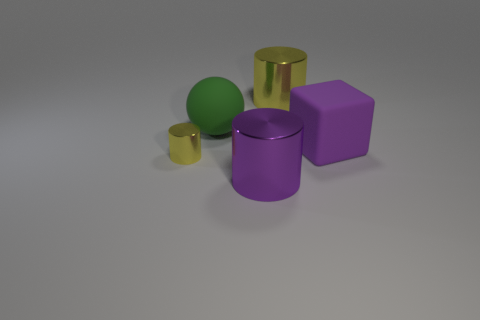What materials do the objects in the image appear to be made of? The objects in the image appear to be rendered digitally and simulate the look of different materials. The cylinders and the cube on the right have a metallic sheen, suggesting they are made of metal, while the sphere has a matte surface, which may indicate a plastic or painted wooden material. 